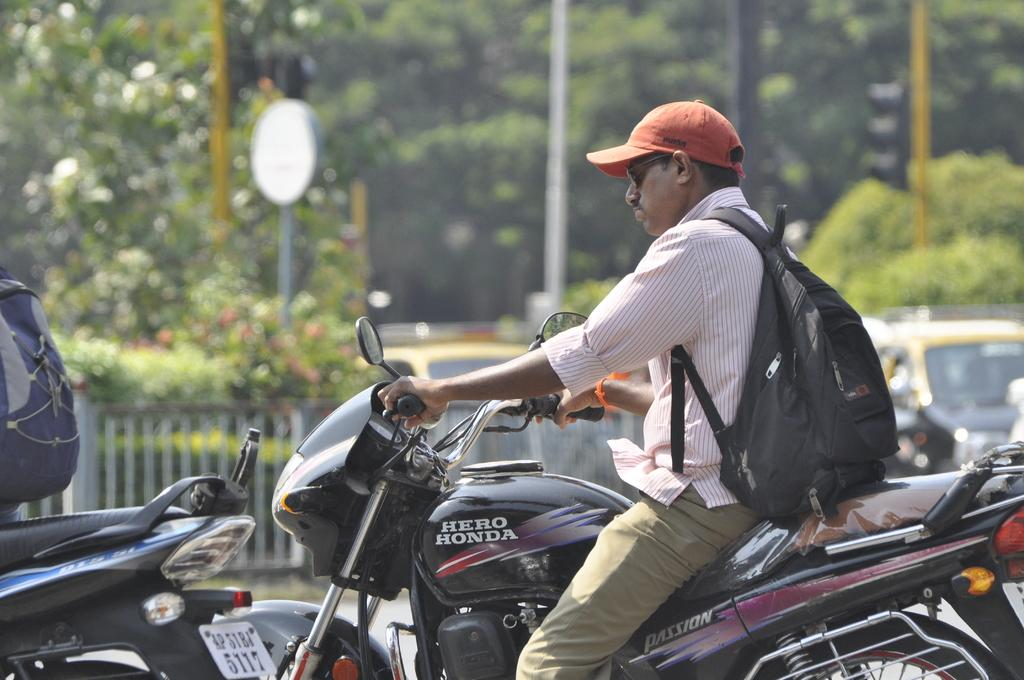What is the person in the image doing? The person is riding a bike. What can be seen on the person's head? The person is wearing a red cap. What is the person carrying while riding the bike? The person is carrying a backpack. What is visible in the background of the image? There are trees in the background of the image. What type of leaf is the person holding in the image? There is no leaf present in the image; the person is riding a bike and wearing a red cap. 